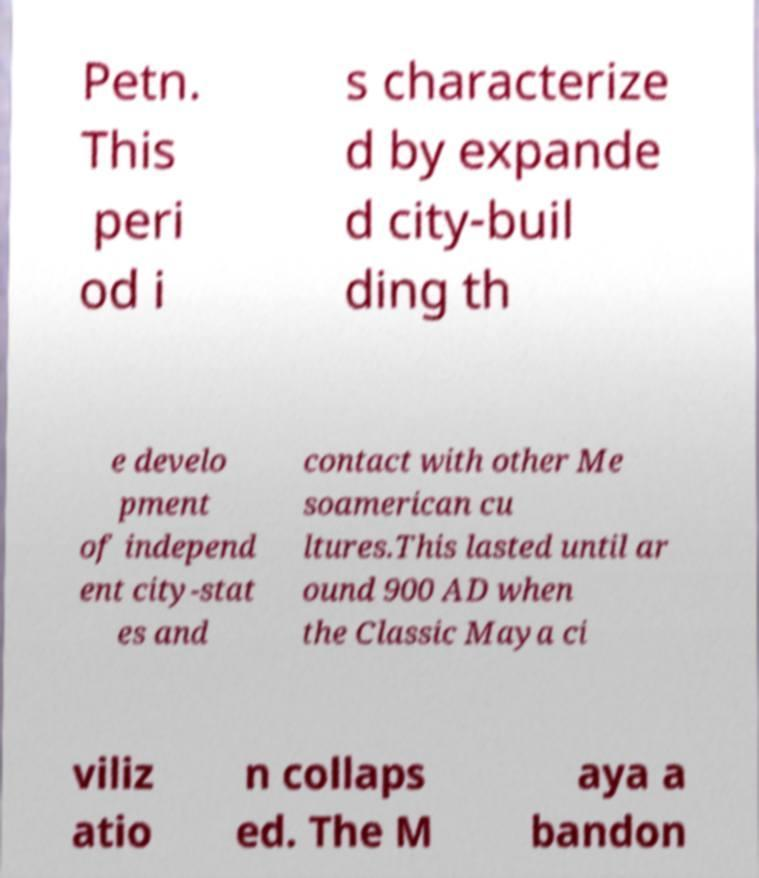Can you accurately transcribe the text from the provided image for me? Petn. This peri od i s characterize d by expande d city-buil ding th e develo pment of independ ent city-stat es and contact with other Me soamerican cu ltures.This lasted until ar ound 900 AD when the Classic Maya ci viliz atio n collaps ed. The M aya a bandon 